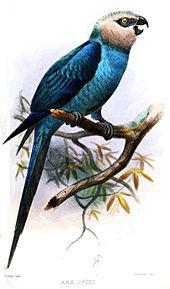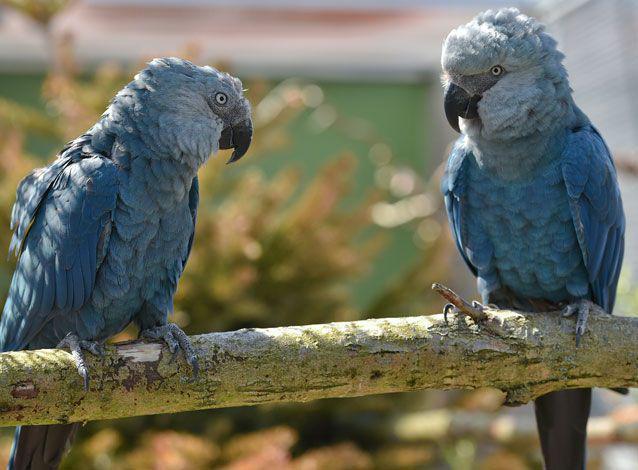The first image is the image on the left, the second image is the image on the right. Given the left and right images, does the statement "There are two birds in the left image and one bird in the right image." hold true? Answer yes or no. No. 